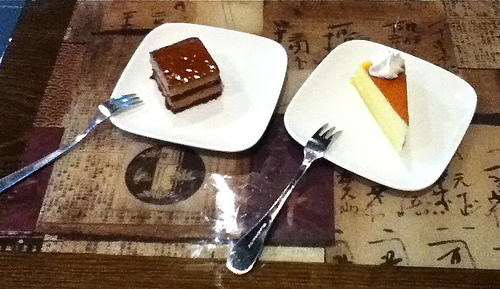<image>
Is the fork to the right of the plate? No. The fork is not to the right of the plate. The horizontal positioning shows a different relationship. Is the fork to the right of the cake? No. The fork is not to the right of the cake. The horizontal positioning shows a different relationship. Is the fork on the plate? Yes. Looking at the image, I can see the fork is positioned on top of the plate, with the plate providing support. Is there a pie on the table? Yes. Looking at the image, I can see the pie is positioned on top of the table, with the table providing support. Is the fork on the plate? No. The fork is not positioned on the plate. They may be near each other, but the fork is not supported by or resting on top of the plate. Is there a plate under the fork? Yes. The plate is positioned underneath the fork, with the fork above it in the vertical space. 